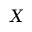<formula> <loc_0><loc_0><loc_500><loc_500>X</formula> 